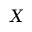<formula> <loc_0><loc_0><loc_500><loc_500>X</formula> 